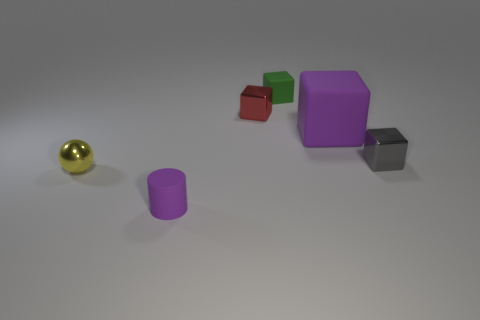Add 3 tiny rubber blocks. How many objects exist? 9 Subtract all blue cubes. Subtract all yellow cylinders. How many cubes are left? 4 Subtract all cylinders. How many objects are left? 5 Add 1 big red rubber things. How many big red rubber things exist? 1 Subtract 0 green spheres. How many objects are left? 6 Subtract all tiny yellow cylinders. Subtract all small gray metallic objects. How many objects are left? 5 Add 2 small red shiny objects. How many small red shiny objects are left? 3 